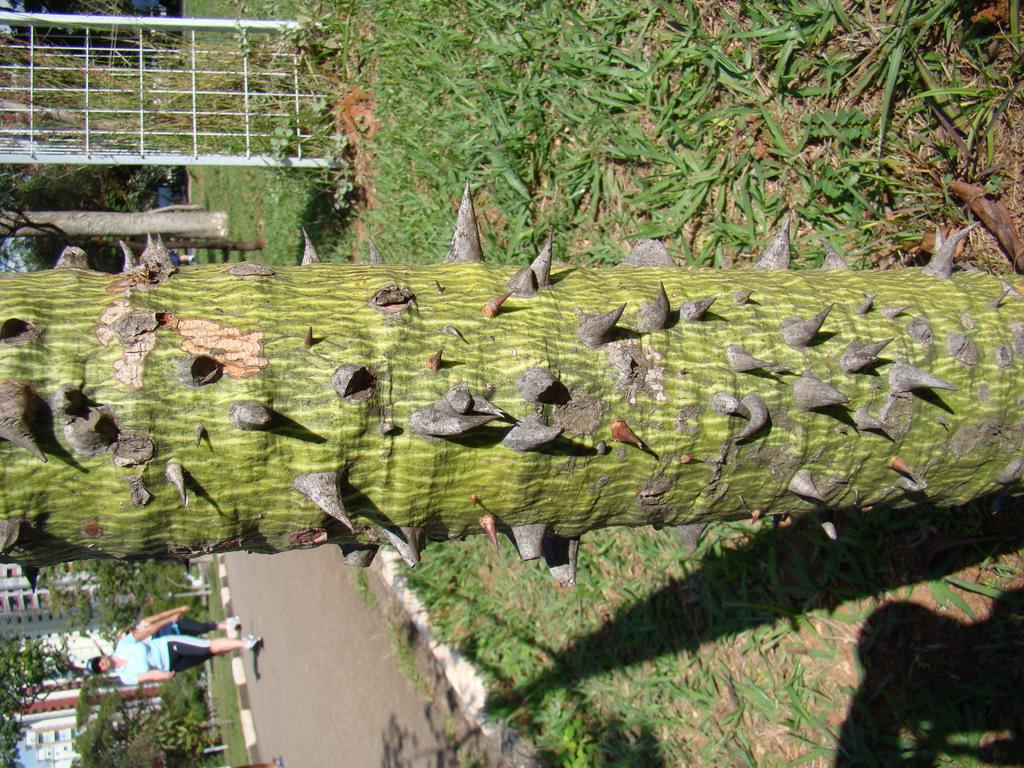What type of tree is in the image? There is a green color tree in the image. What color are the plants on the ground? The plants on the ground are green color. What is on the left side of the image? There is a road on the left side of the image. What is happening on the road? A person is walking on the road. Can you tell me how many beetles are crawling on the person walking on the road? There is no beetle present on the person walking on the road in the image. What is the person's attention focused on while walking on the road? The image does not provide information about the person's attention, so we cannot determine what they are focused on. 